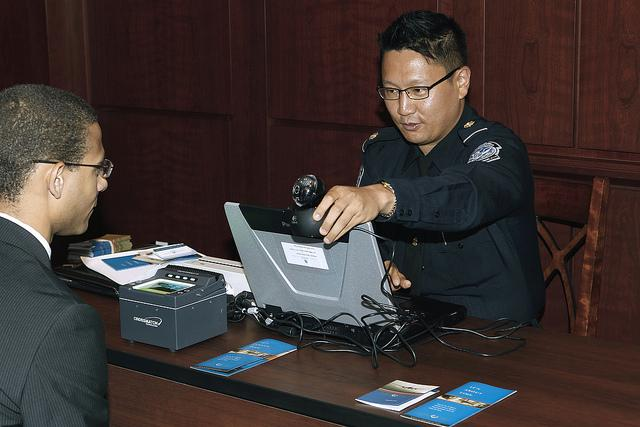What is the person with the laptop taking? picture 